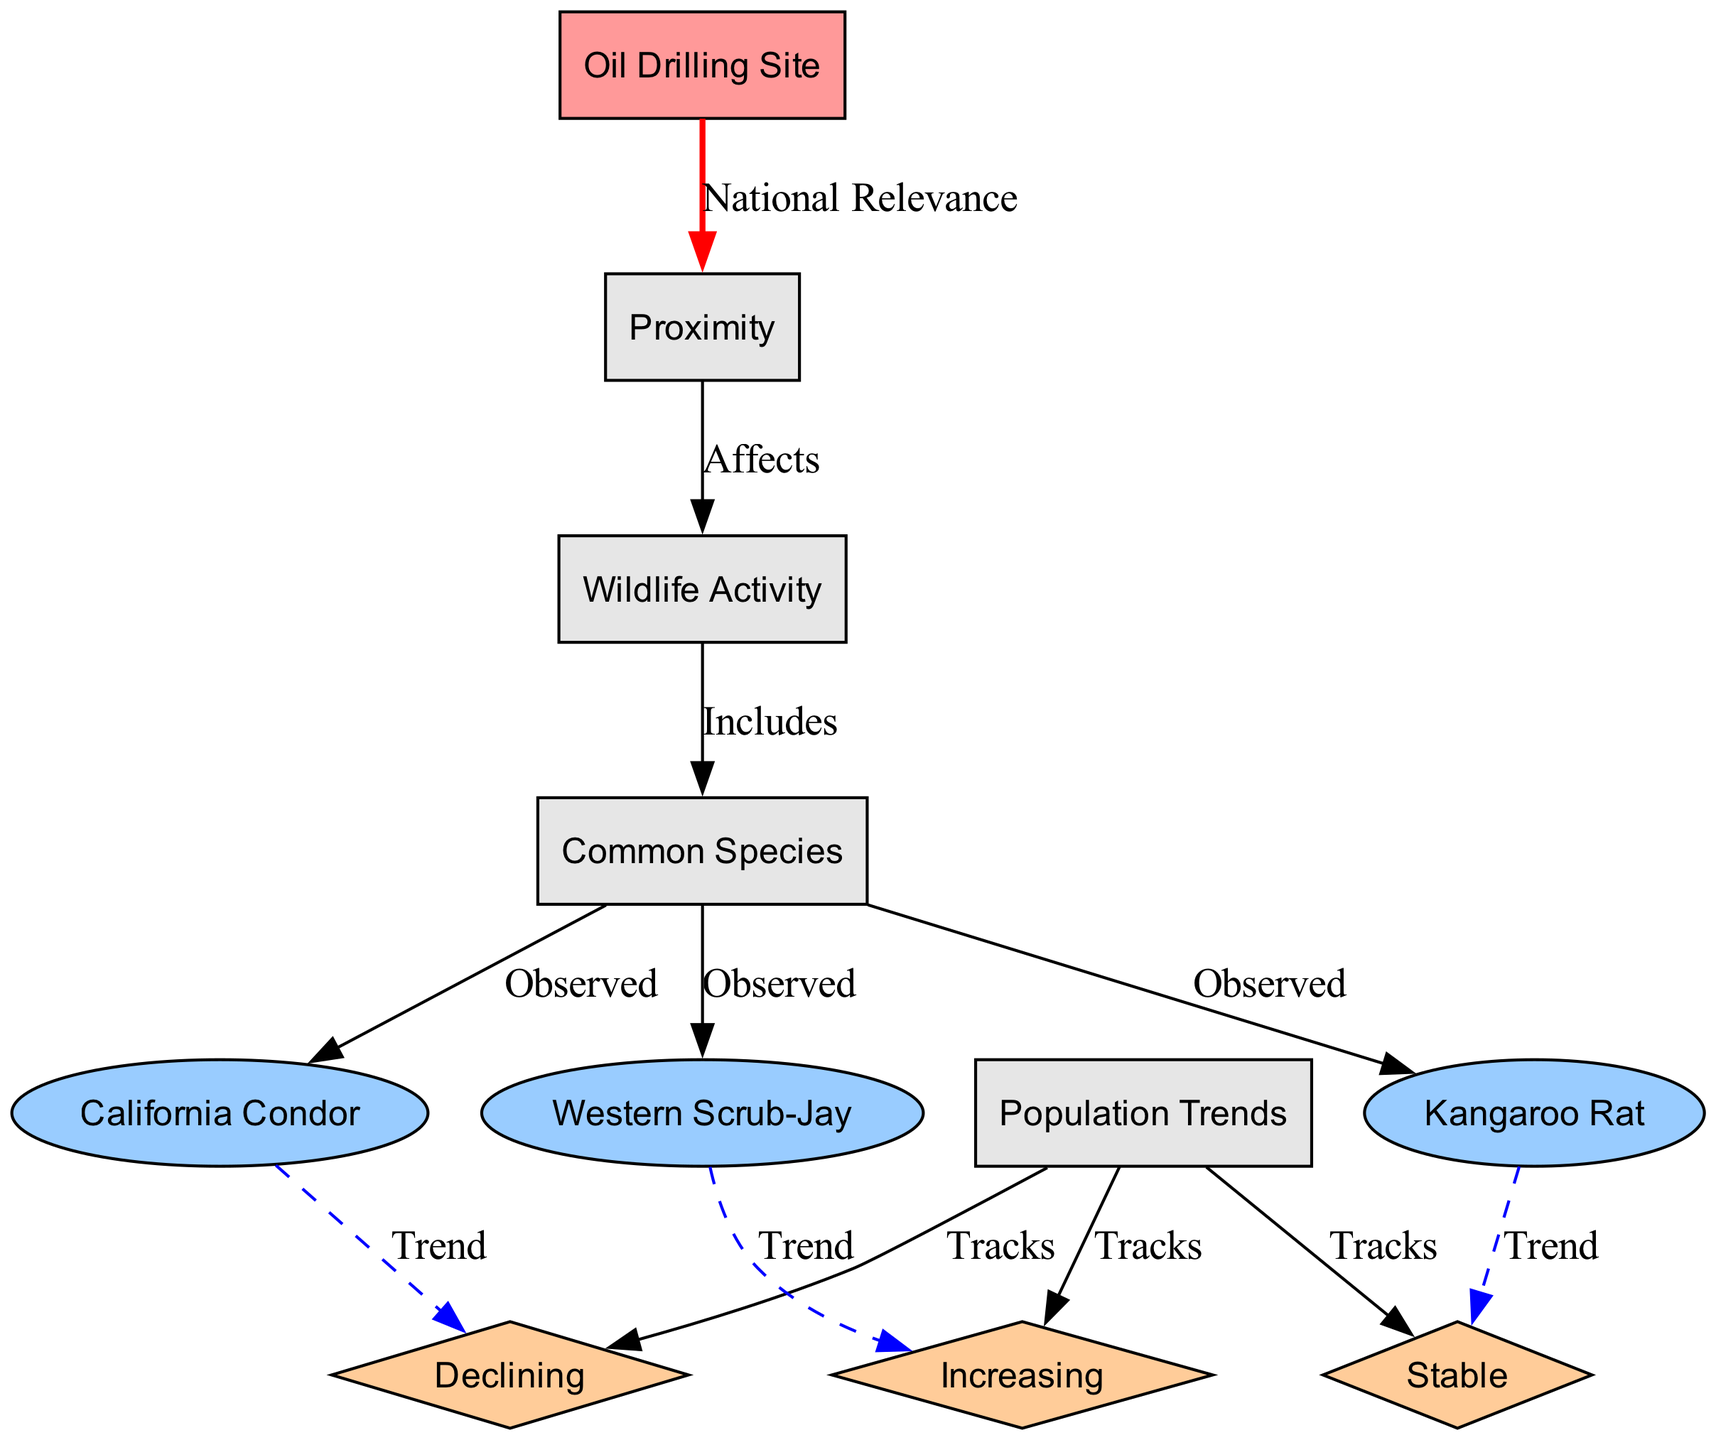What are the common species observed near the oil drilling site? The diagram indicates three species: California Condor, Kangaroo Rat, and Western Scrub-Jay are observed near the oil drilling site.
Answer: California Condor, Kangaroo Rat, Western Scrub-Jay What is the population trend of the California Condor? The diagram shows that the trend for the California Condor is declining as indicated in the relationship from the California Condor node to the trend node.
Answer: Declining How many species are observed in total? The diagram lists three species observed: California Condor, Kangaroo Rat, and Western Scrub-Jay, making the total count three.
Answer: 3 What affects wildlife activity according to the diagram? The diagram reveals that proximity to the oil drilling site affects wildlife activity as shown by the directed edge between these two nodes.
Answer: Proximity Which species has a stable population trend? The diagram indicates that the Kangaroo Rat has a stable population trend based on the relationship drawn from the species node to the trend node.
Answer: Stable How does wildlife activity relate to common species? The diagram illustrates that wildlife activity includes common species, establishing a direct connection with an edge from wildlife activity to common species.
Answer: Includes What is the trend for the Western Scrub-Jay? According to the diagram, the trend for the Western Scrub-Jay is increasing, which is directly linked from the species node to its trend node.
Answer: Increasing What is the connection between the oil drilling site and population trends? The diagram doesn’t explicitly connect the oil drilling site to population trends, indicating that while the site may impact wildlife activity, trends are tracked separately for each species.
Answer: National Relevance How many edges are depicted in the diagram? By counting the directed edges that connect nodes, the total number of edges in the diagram is twelve.
Answer: 12 